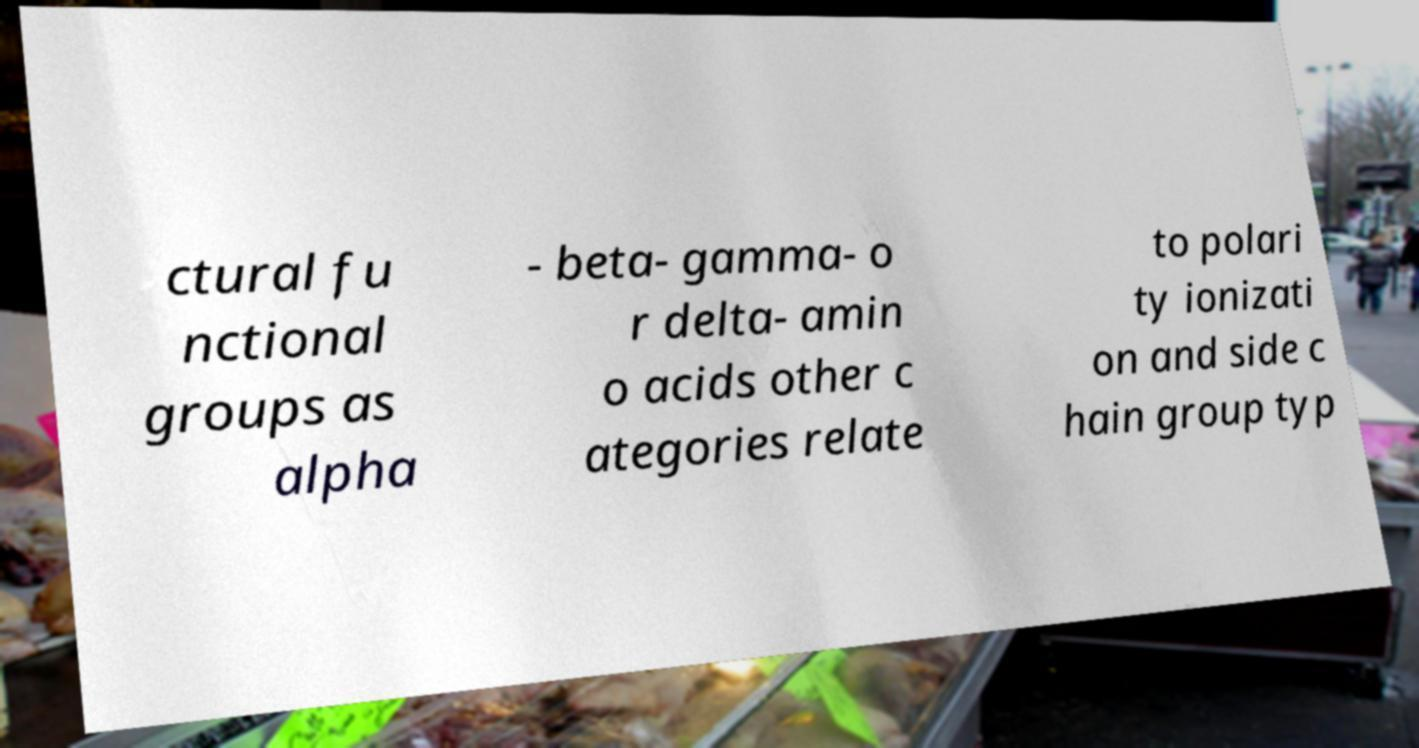Can you accurately transcribe the text from the provided image for me? ctural fu nctional groups as alpha - beta- gamma- o r delta- amin o acids other c ategories relate to polari ty ionizati on and side c hain group typ 